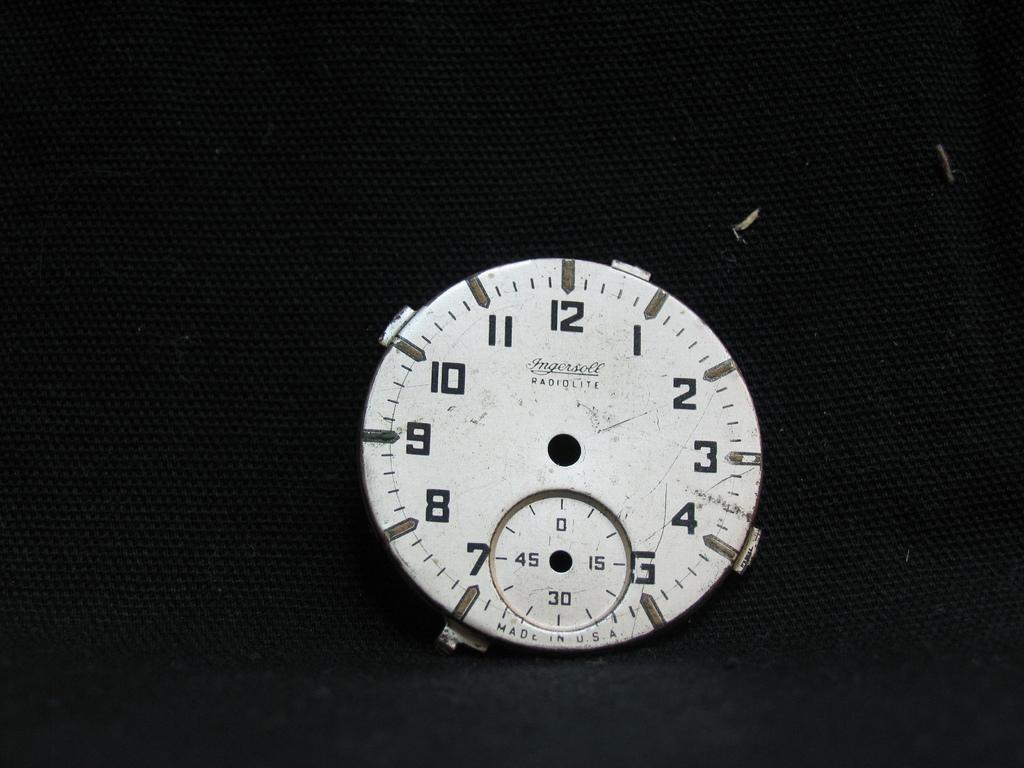What is the furthest right number on the watch face?
Provide a short and direct response. 3. What brand is the clock?
Your answer should be very brief. Ingersoll. 